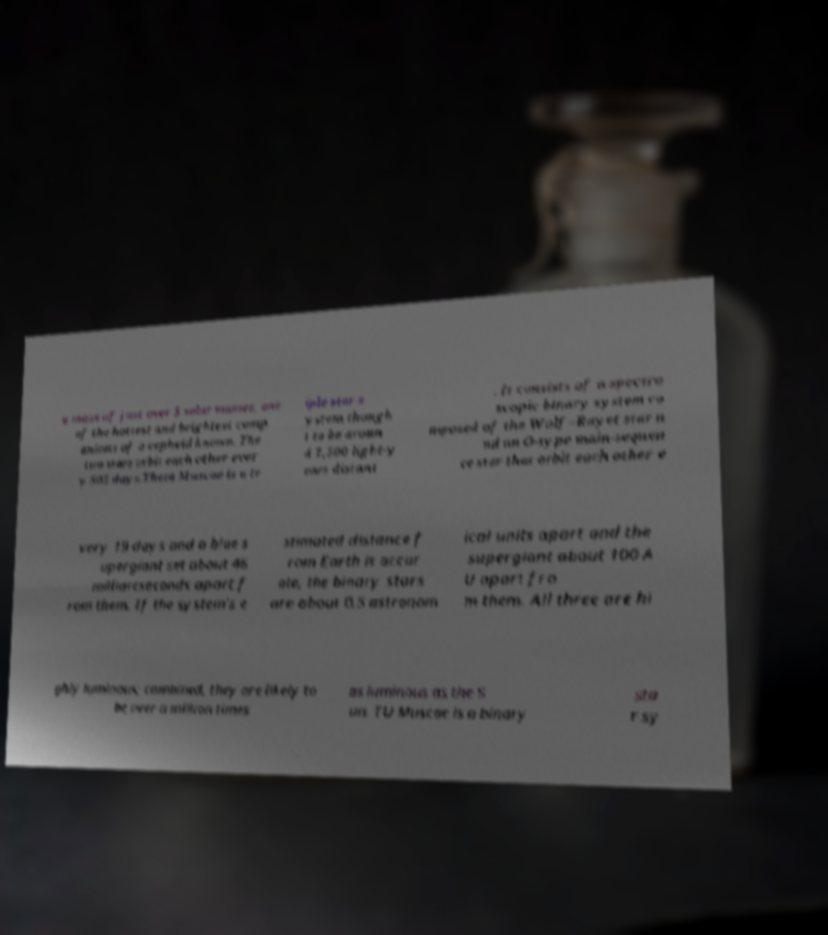For documentation purposes, I need the text within this image transcribed. Could you provide that? a mass of just over 5 solar masses, one of the hottest and brightest comp anions of a cepheid known. The two stars orbit each other ever y 505 days.Theta Muscae is a tr iple star s ystem though t to be aroun d 7,500 light-y ears distant . It consists of a spectro scopic binary system co mposed of the Wolf–Rayet star a nd an O-type main-sequen ce star that orbit each other e very 19 days and a blue s upergiant set about 46 milliarcseconds apart f rom them. If the system's e stimated distance f rom Earth is accur ate, the binary stars are about 0.5 astronom ical units apart and the supergiant about 100 A U apart fro m them. All three are hi ghly luminous; combined, they are likely to be over a million times as luminous as the S un. TU Muscae is a binary sta r sy 